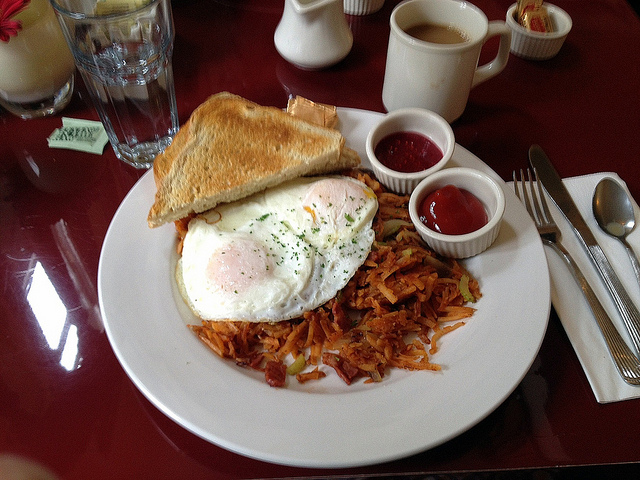Can you describe how this breakfast might taste? Certainly! The breakfast in the image looks delightful. The eggs appear perfectly cooked with a delicate balance between the soft, runny yolk and the firm white, providing a rich, creamy texture. The toasted bread looks crispy and golden, likely giving a satisfying crunch with each bite. The hash browns seem crispy on the outside and tender on the inside, offering a savory and slightly salty flavor. The accompanying condiments, such as what appears to be ketchup and perhaps a berry jam, add contrasting sweet and tangy notes that enhance the overall taste experience. Together, this breakfast is likely to be a delicious blend of flavors and textures that are comforting and satisfying. 